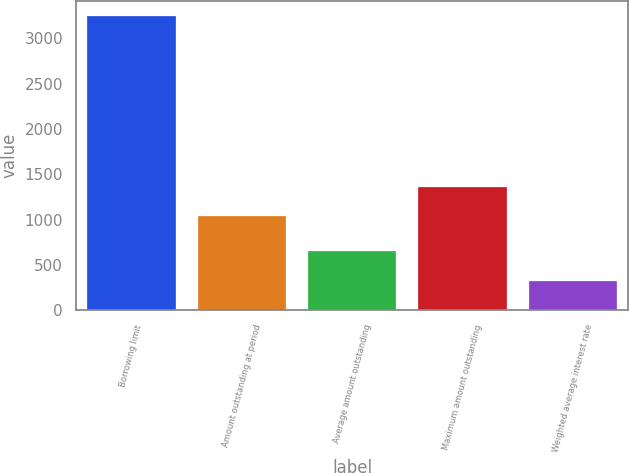<chart> <loc_0><loc_0><loc_500><loc_500><bar_chart><fcel>Borrowing limit<fcel>Amount outstanding at period<fcel>Average amount outstanding<fcel>Maximum amount outstanding<fcel>Weighted average interest rate<nl><fcel>3250<fcel>1038<fcel>652.2<fcel>1362.72<fcel>327.48<nl></chart> 